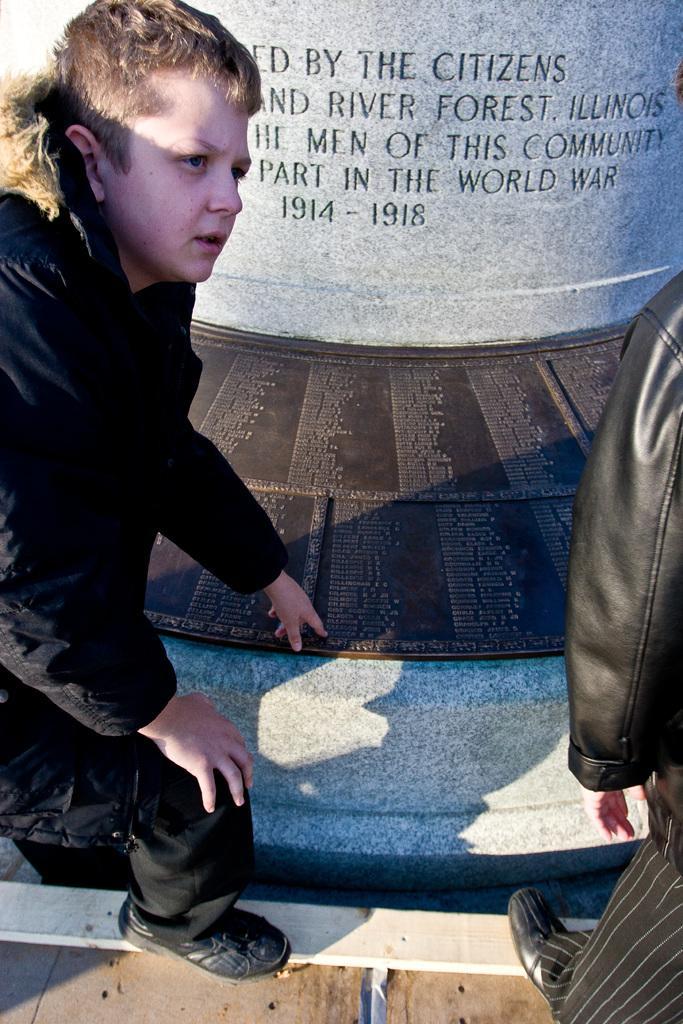Could you give a brief overview of what you see in this image? In this image on the right side and left side there are two persons, and at the bottom there is walkway and some boards. On the boards there is some text, and in the center there is a pillar. On the pillar there is some text, and at the bottom there is a wooden board. 